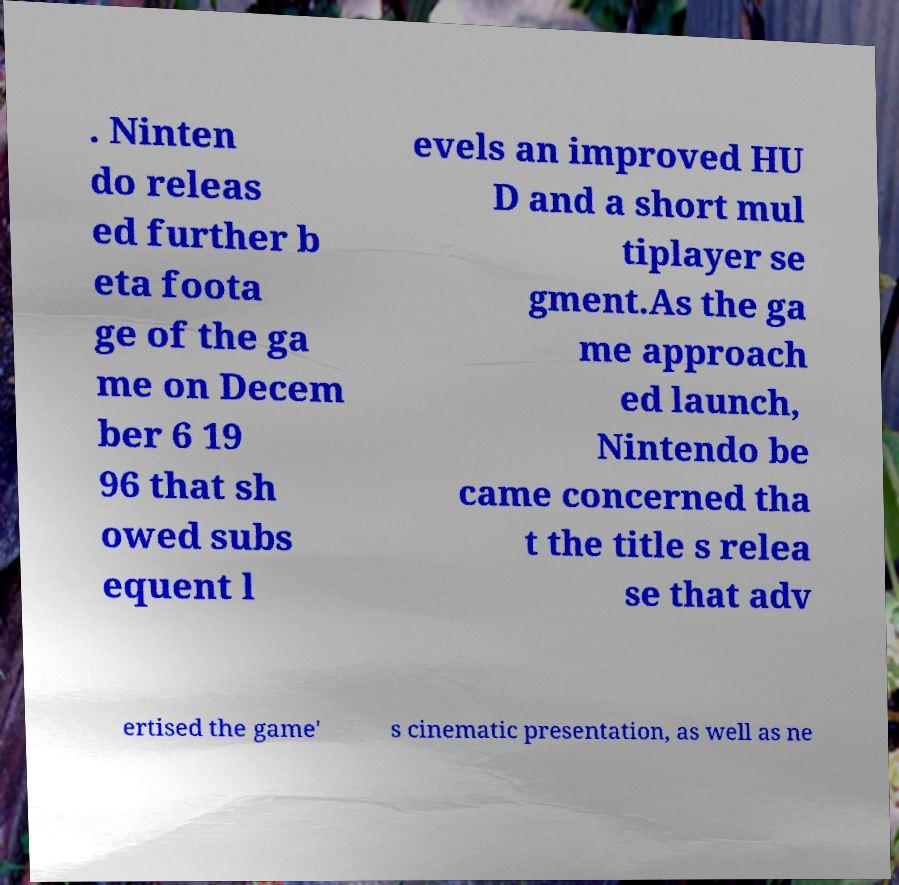Please identify and transcribe the text found in this image. . Ninten do releas ed further b eta foota ge of the ga me on Decem ber 6 19 96 that sh owed subs equent l evels an improved HU D and a short mul tiplayer se gment.As the ga me approach ed launch, Nintendo be came concerned tha t the title s relea se that adv ertised the game' s cinematic presentation, as well as ne 